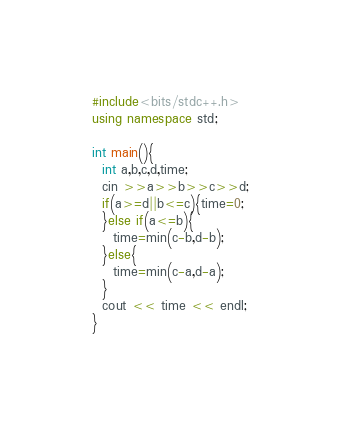<code> <loc_0><loc_0><loc_500><loc_500><_C++_>#include<bits/stdc++.h>
using namespace std;

int main(){
  int a,b,c,d,time;
  cin >>a>>b>>c>>d;
  if(a>=d||b<=c){time=0;
  }else if(a<=b){
    time=min(c-b,d-b);
  }else{
    time=min(c-a,d-a);
  }
  cout << time << endl;
}
</code> 